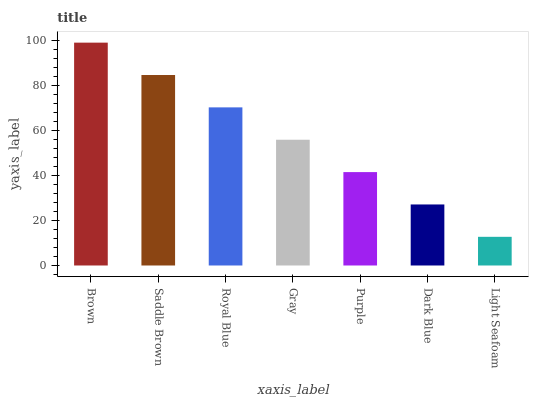Is Light Seafoam the minimum?
Answer yes or no. Yes. Is Brown the maximum?
Answer yes or no. Yes. Is Saddle Brown the minimum?
Answer yes or no. No. Is Saddle Brown the maximum?
Answer yes or no. No. Is Brown greater than Saddle Brown?
Answer yes or no. Yes. Is Saddle Brown less than Brown?
Answer yes or no. Yes. Is Saddle Brown greater than Brown?
Answer yes or no. No. Is Brown less than Saddle Brown?
Answer yes or no. No. Is Gray the high median?
Answer yes or no. Yes. Is Gray the low median?
Answer yes or no. Yes. Is Dark Blue the high median?
Answer yes or no. No. Is Light Seafoam the low median?
Answer yes or no. No. 